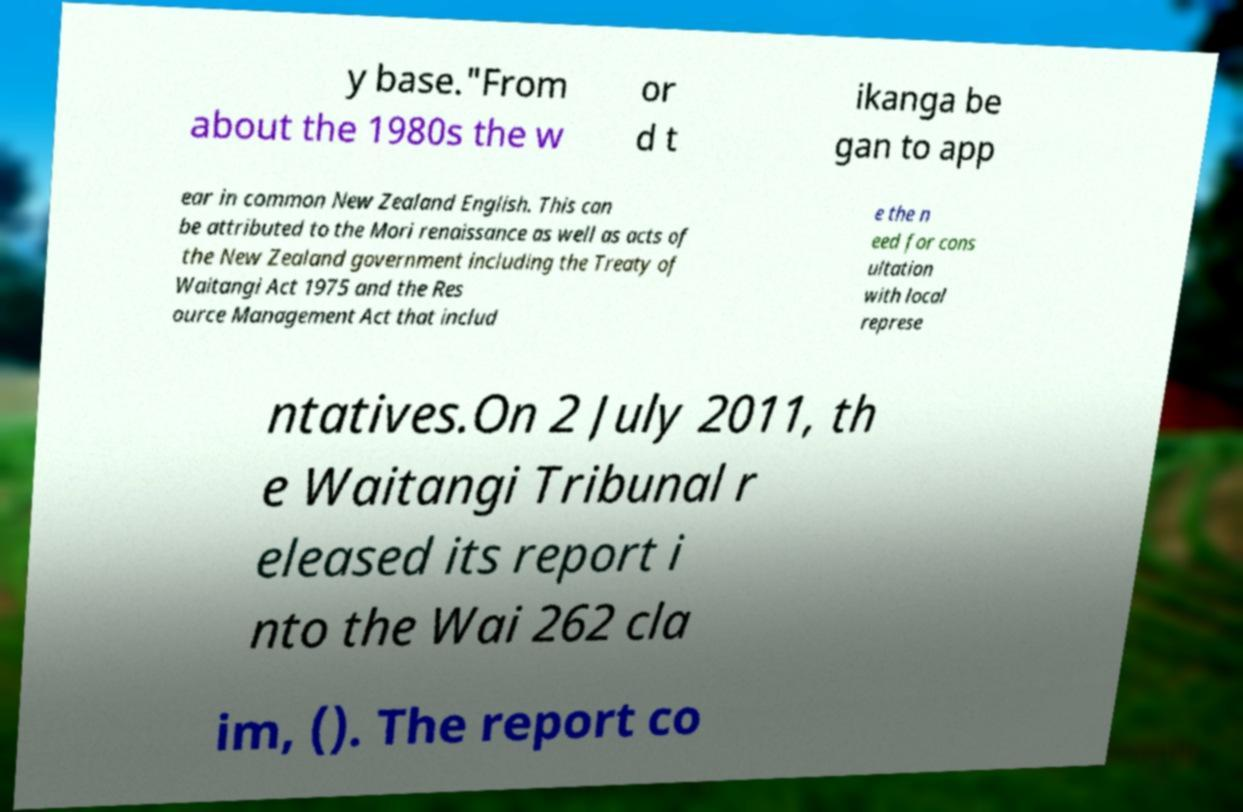Could you extract and type out the text from this image? y base."From about the 1980s the w or d t ikanga be gan to app ear in common New Zealand English. This can be attributed to the Mori renaissance as well as acts of the New Zealand government including the Treaty of Waitangi Act 1975 and the Res ource Management Act that includ e the n eed for cons ultation with local represe ntatives.On 2 July 2011, th e Waitangi Tribunal r eleased its report i nto the Wai 262 cla im, (). The report co 